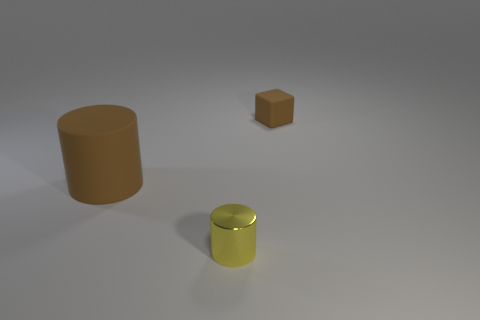Is the number of gray metallic blocks less than the number of blocks?
Provide a short and direct response. Yes. Are there more big blue rubber spheres than brown cylinders?
Ensure brevity in your answer.  No. How many other objects are the same material as the large object?
Provide a short and direct response. 1. What number of small shiny cylinders are to the right of the brown object on the left side of the brown thing that is to the right of the tiny yellow cylinder?
Your answer should be very brief. 1. How many shiny objects are tiny brown cubes or small purple objects?
Provide a succinct answer. 0. There is a rubber thing behind the object on the left side of the yellow shiny thing; what size is it?
Give a very brief answer. Small. There is a small object in front of the tiny matte cube; is its color the same as the rubber thing that is behind the big matte cylinder?
Provide a succinct answer. No. There is a object that is to the right of the big cylinder and behind the yellow metal cylinder; what color is it?
Make the answer very short. Brown. Are the large brown cylinder and the yellow cylinder made of the same material?
Give a very brief answer. No. How many tiny objects are either cubes or yellow objects?
Offer a very short reply. 2. 